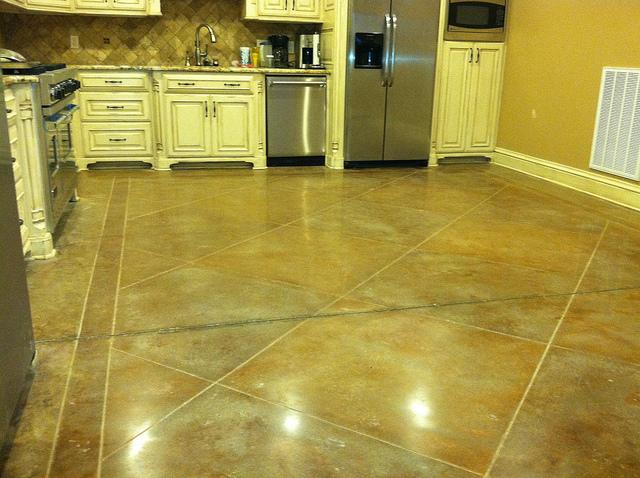What room of the house is this?
Short answer required. Kitchen. What material is the floor made of?
Be succinct. Tile. How many lights are reflected on the floor?
Write a very short answer. 3. 